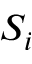Convert formula to latex. <formula><loc_0><loc_0><loc_500><loc_500>S _ { i }</formula> 